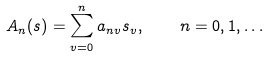<formula> <loc_0><loc_0><loc_500><loc_500>A _ { n } ( s ) = \sum _ { v = 0 } ^ { n } a _ { n v } s _ { v } , \quad n = 0 , 1 , \dots</formula> 